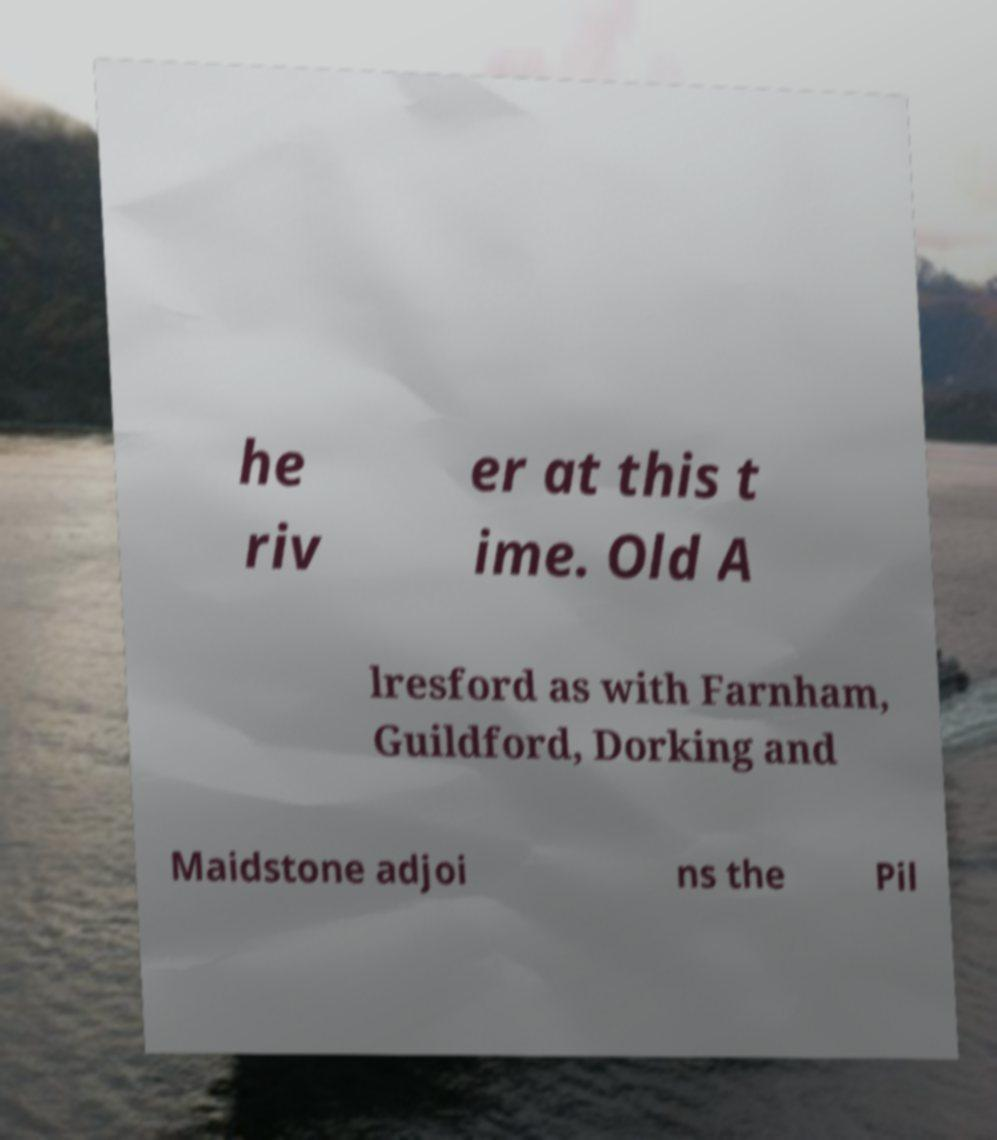Please read and relay the text visible in this image. What does it say? he riv er at this t ime. Old A lresford as with Farnham, Guildford, Dorking and Maidstone adjoi ns the Pil 